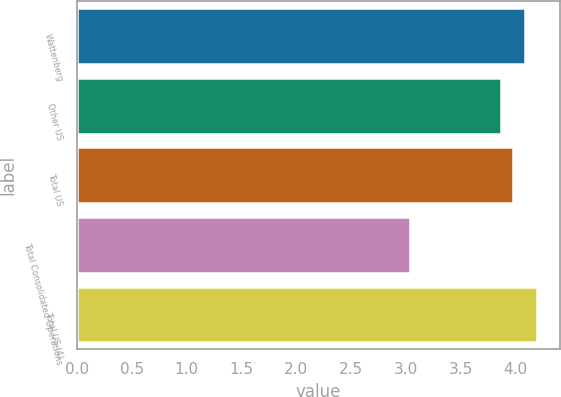<chart> <loc_0><loc_0><loc_500><loc_500><bar_chart><fcel>Wattenberg<fcel>Other US<fcel>Total US<fcel>Total Consolidated Operations<fcel>Total US (4)<nl><fcel>4.09<fcel>3.87<fcel>3.98<fcel>3.04<fcel>4.2<nl></chart> 